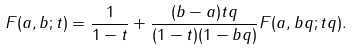<formula> <loc_0><loc_0><loc_500><loc_500>F ( a , b ; t ) = \frac { 1 } { 1 - t } + \frac { ( b - a ) t q } { ( 1 - t ) ( 1 - b q ) } F ( a , b q ; t q ) .</formula> 